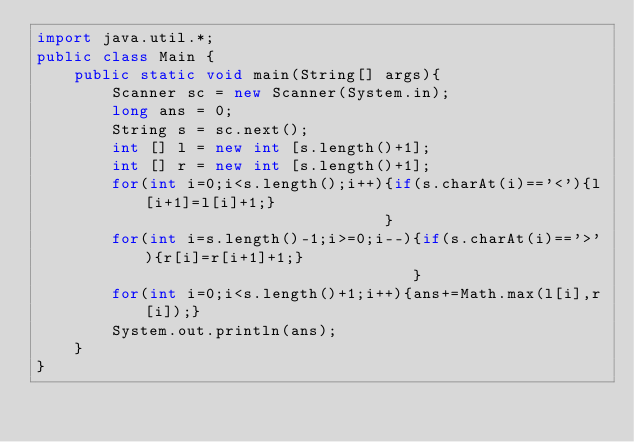<code> <loc_0><loc_0><loc_500><loc_500><_Java_>import java.util.*;
public class Main {
	public static void main(String[] args){
		Scanner sc = new Scanner(System.in);
		long ans = 0;
		String s = sc.next();
        int [] l = new int [s.length()+1];
        int [] r = new int [s.length()+1];        
        for(int i=0;i<s.length();i++){if(s.charAt(i)=='<'){l[i+1]=l[i]+1;}
                                     }
        for(int i=s.length()-1;i>=0;i--){if(s.charAt(i)=='>'){r[i]=r[i+1]+1;}
                                        }
        for(int i=0;i<s.length()+1;i++){ans+=Math.max(l[i],r[i]);}      
		System.out.println(ans);
	}
}</code> 